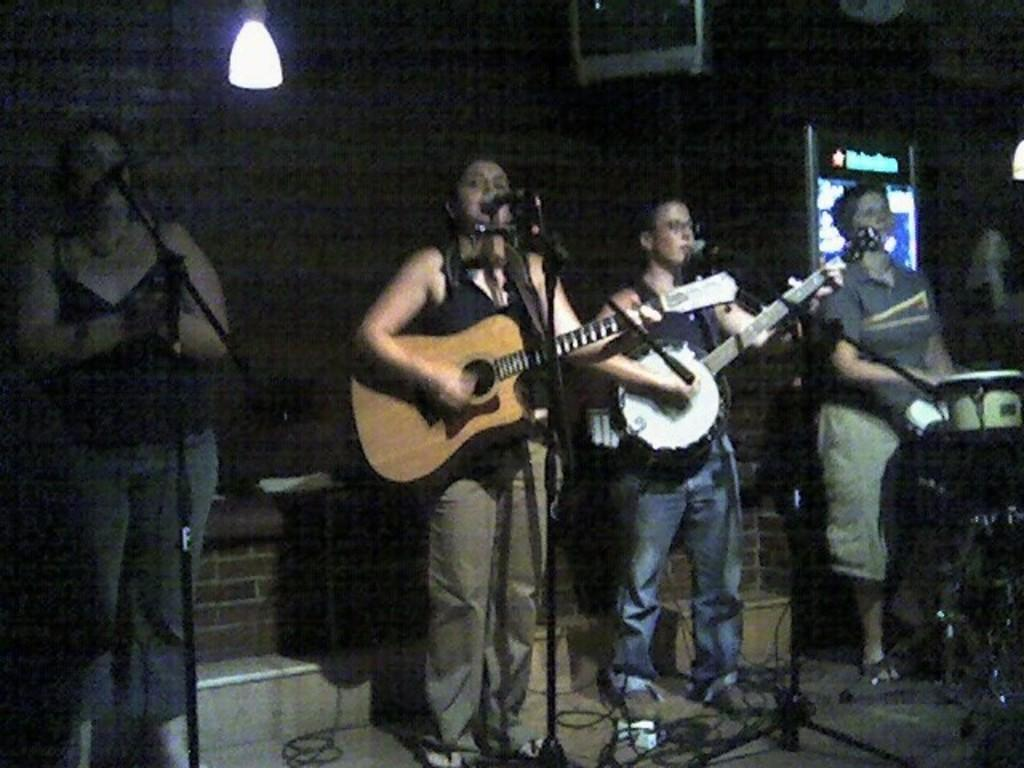What is happening in the image involving the group of people? The people in the image are playing guitar. What object is present in the image that might be used for amplifying sound? There is a microphone in the image. How many people are involved in the activity shown in the image? The image shows a group of people, but the exact number cannot be determined from the provided facts. What type of punishment is being administered to the people in the image? There is no indication of punishment in the image; the people are playing guitar and using a microphone. What kind of hole can be seen in the image? There is no hole present in the image. 